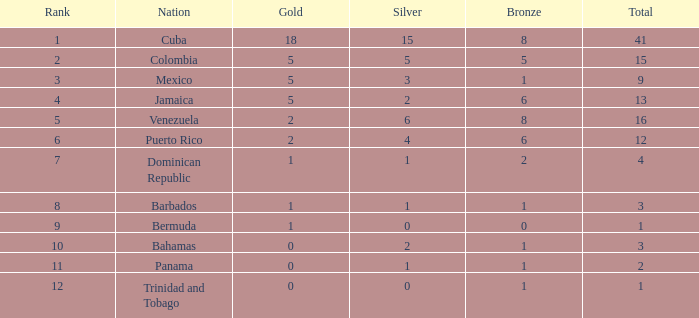Which Bronze is the highest one that has a Rank larger than 1, and a Nation of dominican republic, and a Total larger than 4? None. 